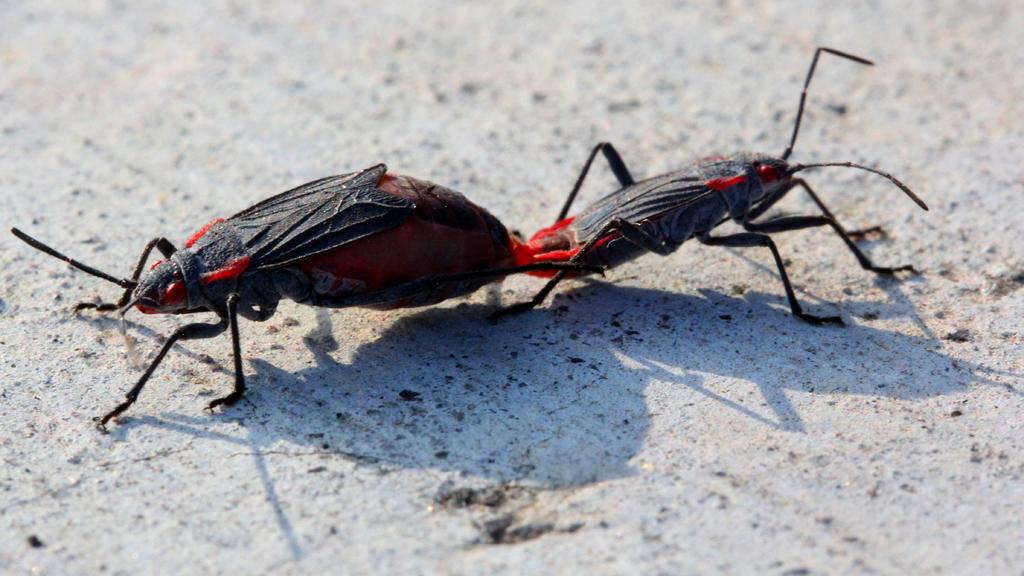How many insects are present in the image? There are two insects in the picture. Where are the insects located in the image? The insects are on the surface in the image. What can be said about the color of the insects? The insects are dark in color. What type of story is being told by the insects in the image? There is no story being told by the insects in the image; they are simply insects on a surface. Can you see any beads in the image? There are no beads present in the image. 